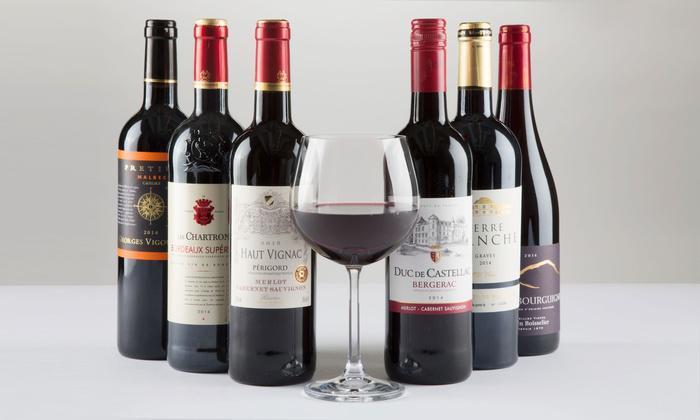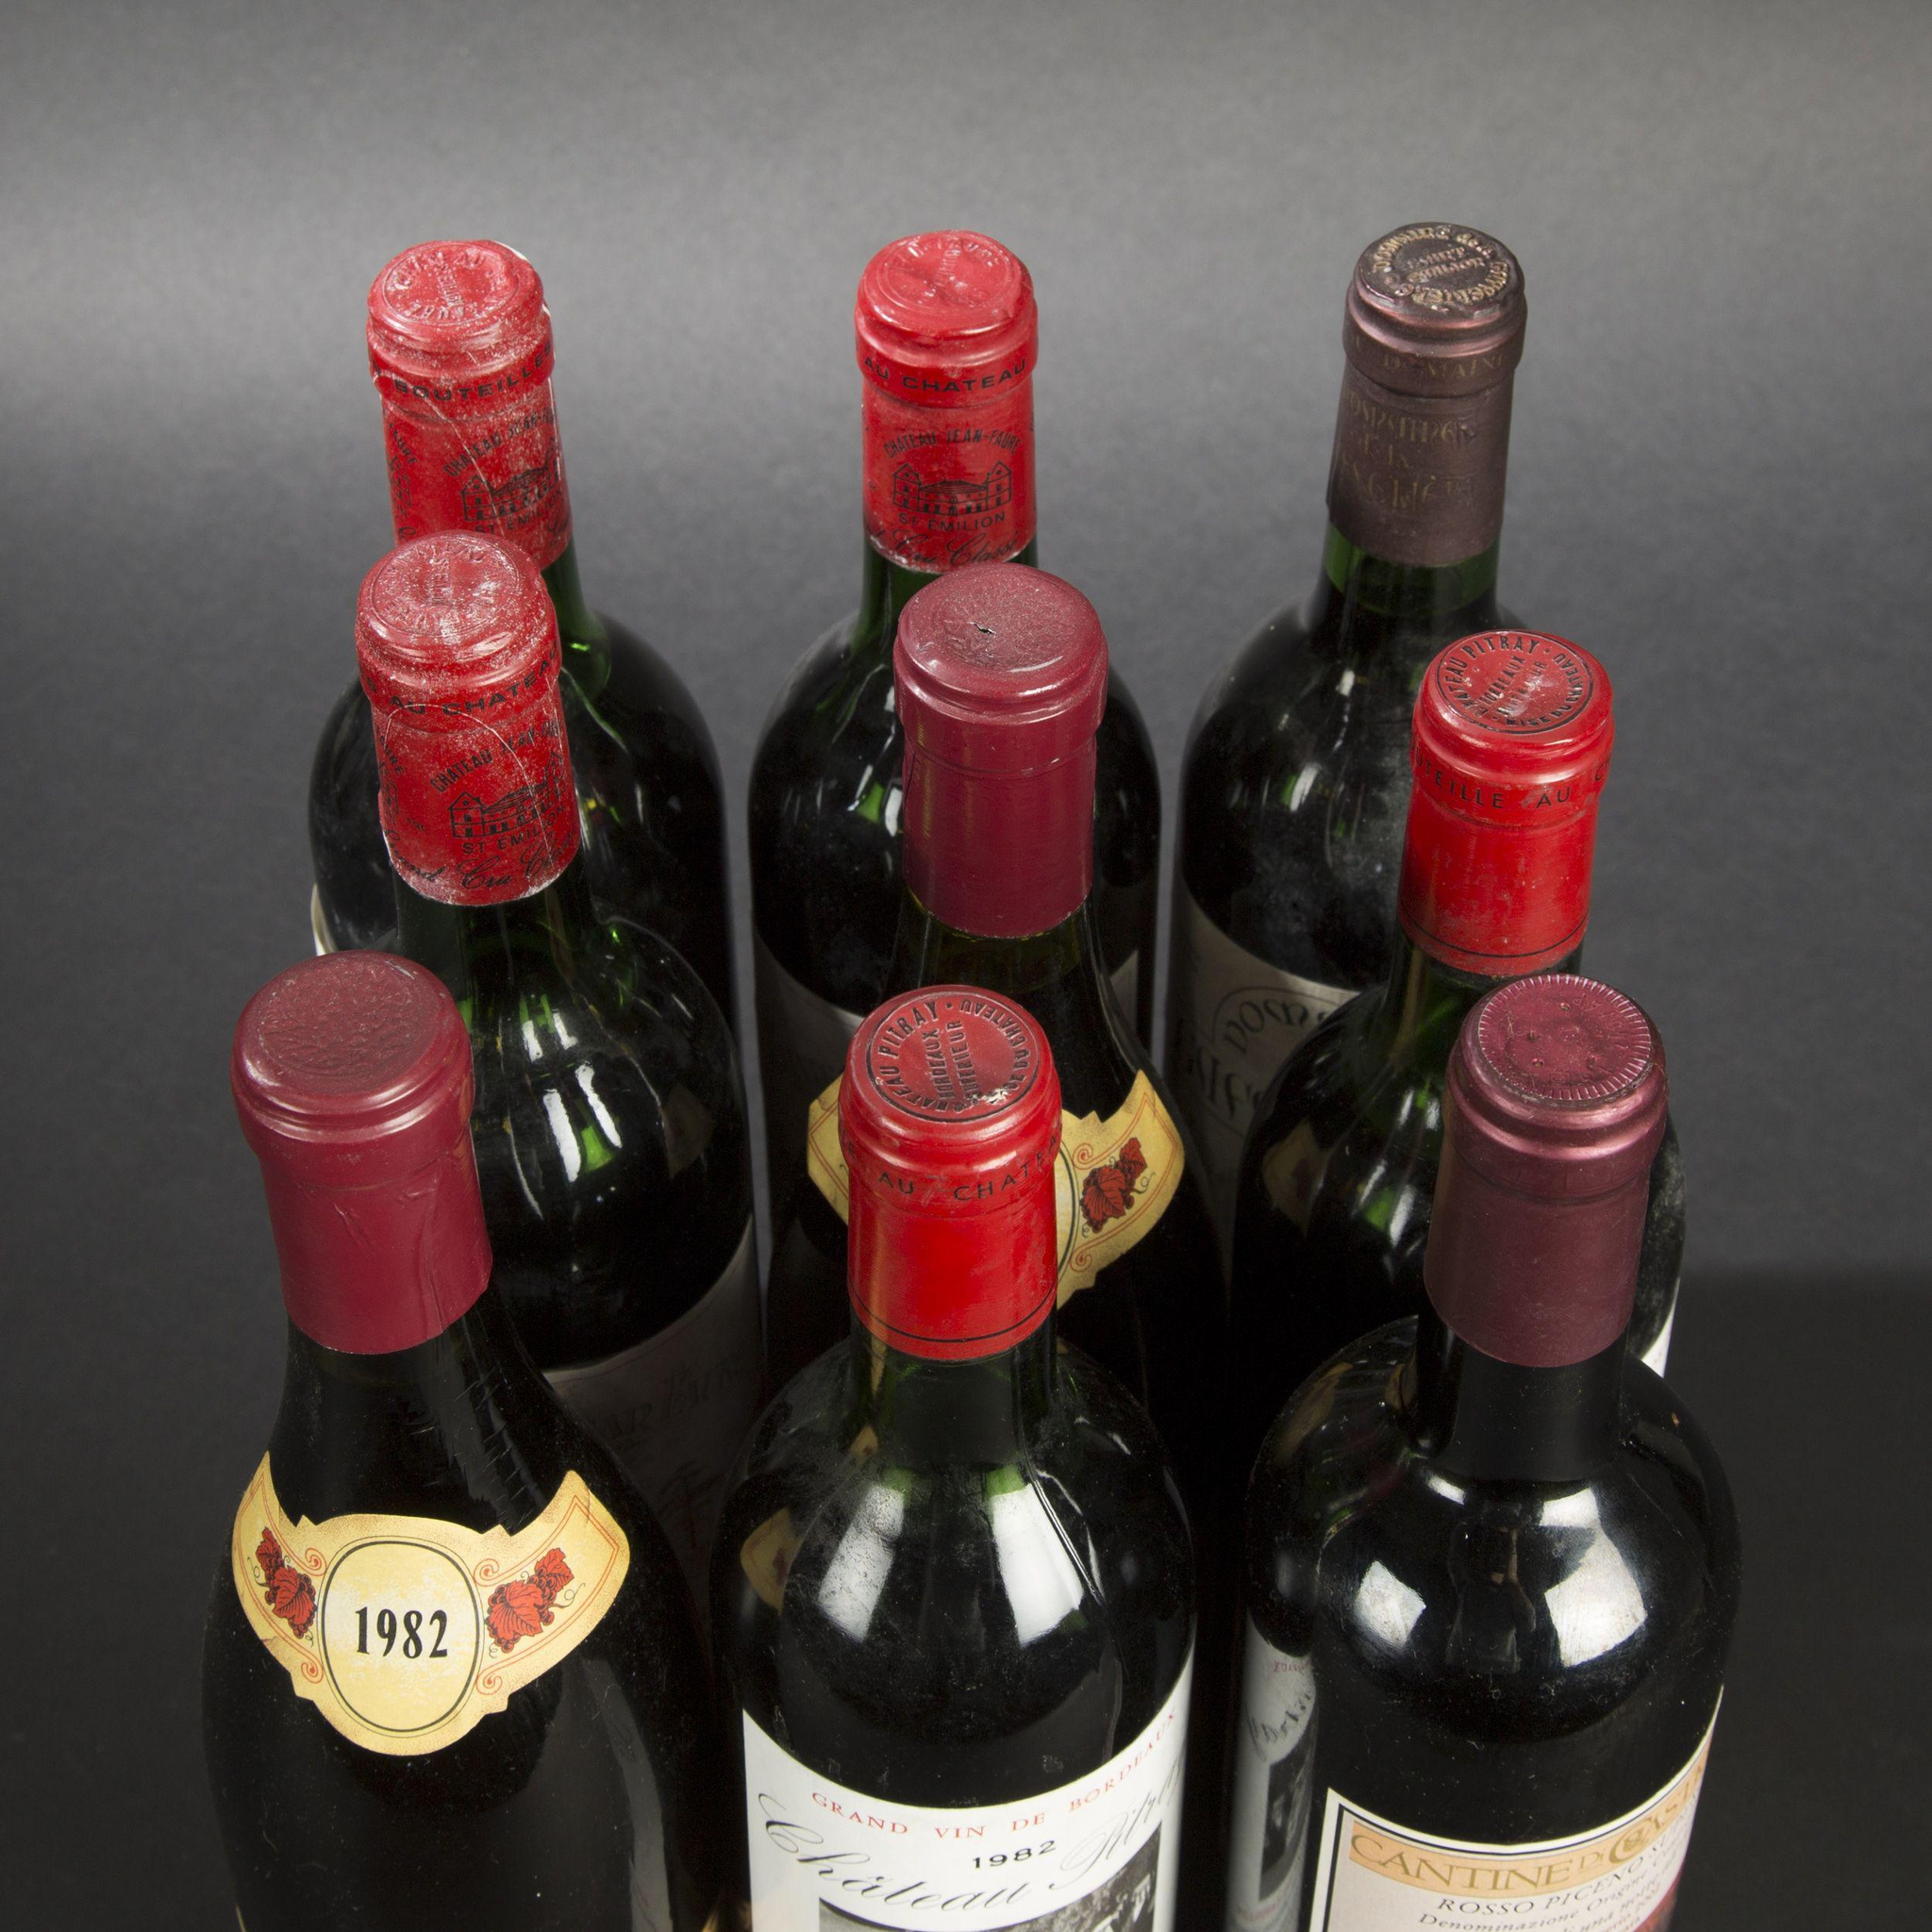The first image is the image on the left, the second image is the image on the right. Analyze the images presented: Is the assertion "A single bottle of wine is shown in one image." valid? Answer yes or no. No. The first image is the image on the left, the second image is the image on the right. Considering the images on both sides, is "An image includes at least one wine bottle and wine glass." valid? Answer yes or no. Yes. 